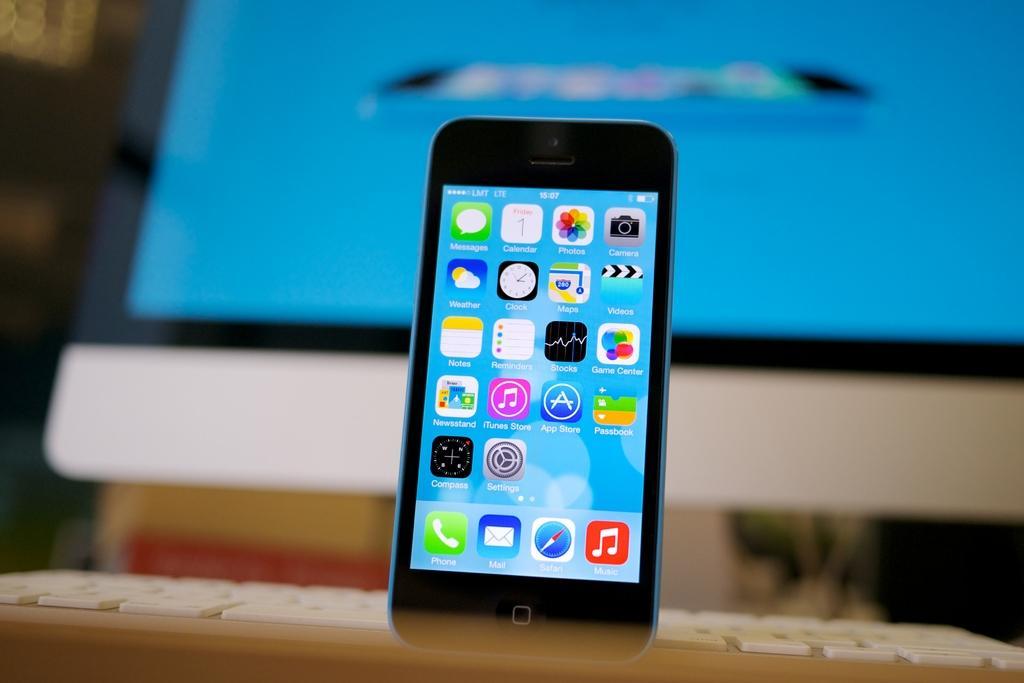Can you describe this image briefly? In this picture I can see mobile with icons. And I can see the keyboard and personal computer. 